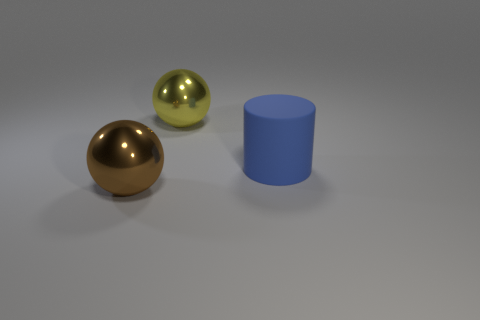How many tiny objects are blue rubber things or yellow shiny spheres?
Ensure brevity in your answer.  0. Is the number of large cylinders greater than the number of spheres?
Provide a succinct answer. No. Are the cylinder and the brown thing made of the same material?
Provide a succinct answer. No. Is there anything else that has the same material as the yellow sphere?
Offer a very short reply. Yes. Is the number of large spheres to the right of the yellow sphere greater than the number of big shiny balls?
Give a very brief answer. No. How many large blue matte objects have the same shape as the brown object?
Keep it short and to the point. 0. The yellow ball that is made of the same material as the large brown thing is what size?
Provide a short and direct response. Large. The thing that is both in front of the big yellow shiny thing and to the left of the blue cylinder is what color?
Your answer should be very brief. Brown. What number of cylinders have the same size as the brown metal sphere?
Provide a succinct answer. 1. What size is the thing that is both in front of the yellow shiny ball and to the left of the blue cylinder?
Provide a succinct answer. Large. 